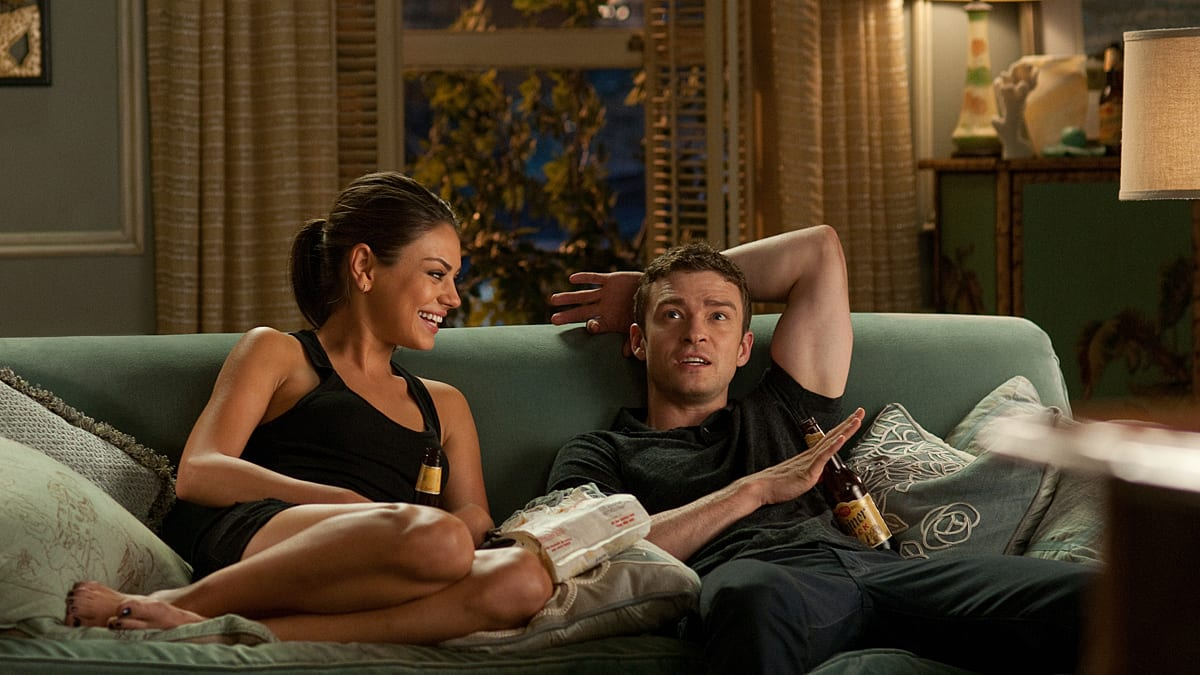What do you think is the topic of their conversation that makes them both so engaged? Given their expressions and relaxed postures, they seem to be sharing a humorous or intriguing story. Perhaps, they are recounting a funny incident or exchanging thoughts on a movie they just watched, which keeps them both visibly entertained and connected. 